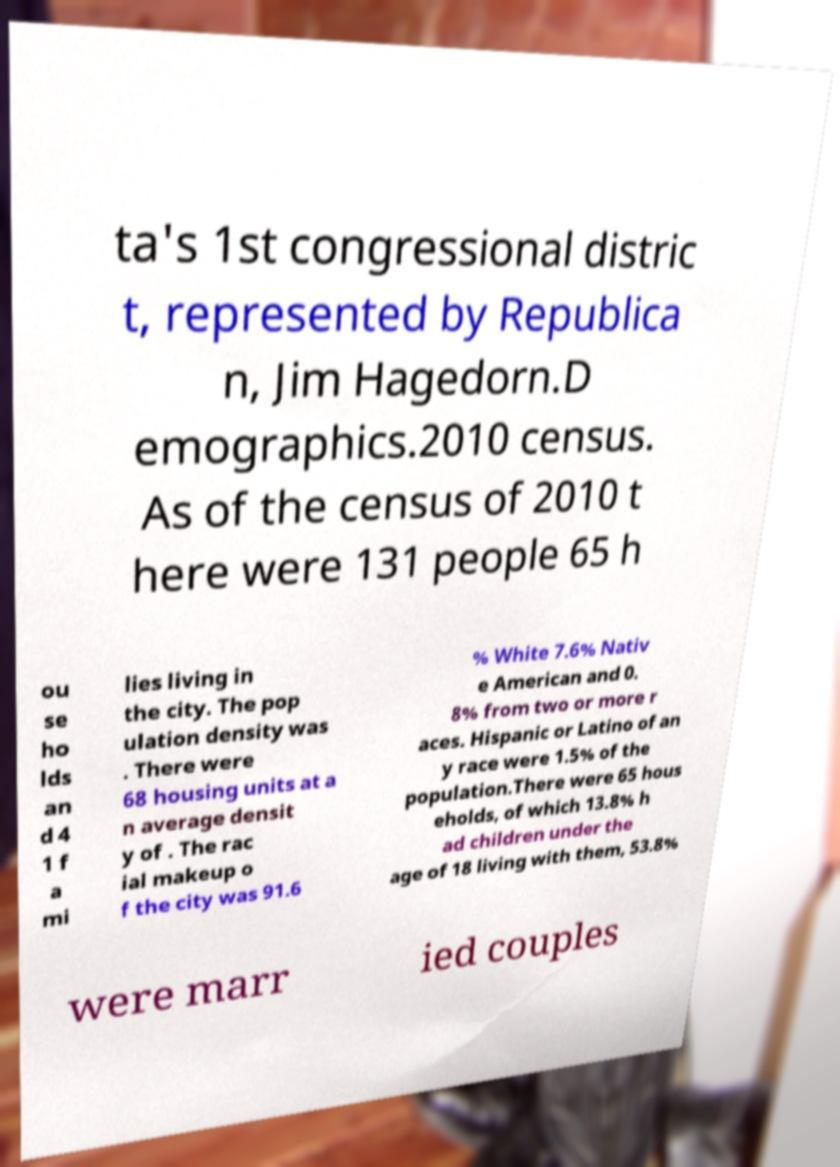There's text embedded in this image that I need extracted. Can you transcribe it verbatim? ta's 1st congressional distric t, represented by Republica n, Jim Hagedorn.D emographics.2010 census. As of the census of 2010 t here were 131 people 65 h ou se ho lds an d 4 1 f a mi lies living in the city. The pop ulation density was . There were 68 housing units at a n average densit y of . The rac ial makeup o f the city was 91.6 % White 7.6% Nativ e American and 0. 8% from two or more r aces. Hispanic or Latino of an y race were 1.5% of the population.There were 65 hous eholds, of which 13.8% h ad children under the age of 18 living with them, 53.8% were marr ied couples 